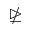<formula> <loc_0><loc_0><loc_500><loc_500>\ntrianglerighteq</formula> 